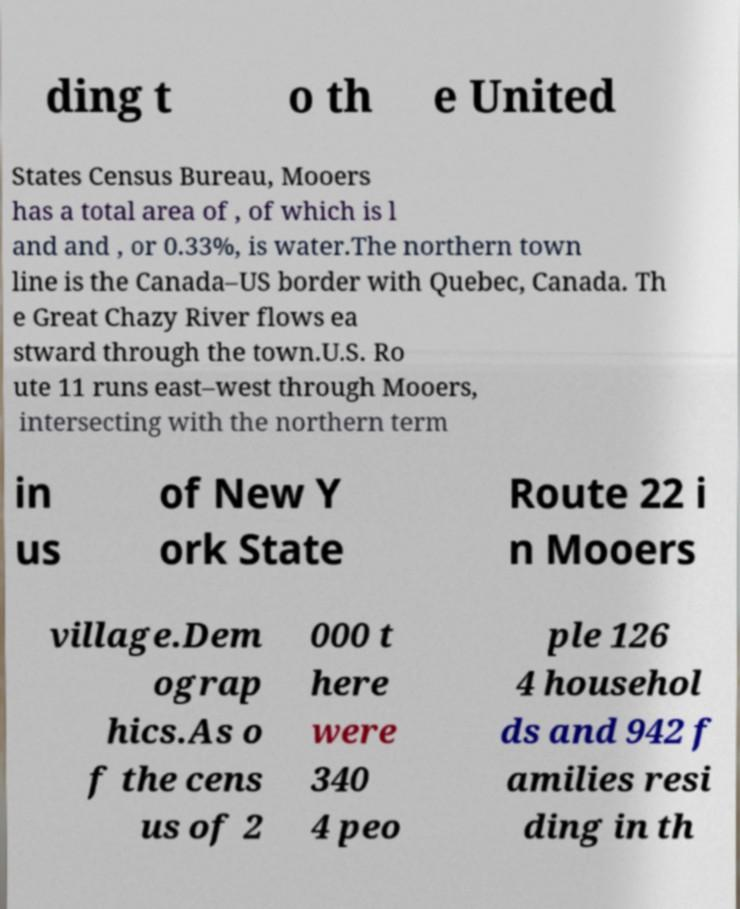Could you extract and type out the text from this image? ding t o th e United States Census Bureau, Mooers has a total area of , of which is l and and , or 0.33%, is water.The northern town line is the Canada–US border with Quebec, Canada. Th e Great Chazy River flows ea stward through the town.U.S. Ro ute 11 runs east–west through Mooers, intersecting with the northern term in us of New Y ork State Route 22 i n Mooers village.Dem ograp hics.As o f the cens us of 2 000 t here were 340 4 peo ple 126 4 househol ds and 942 f amilies resi ding in th 